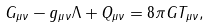<formula> <loc_0><loc_0><loc_500><loc_500>G _ { \mu \nu } - g _ { \mu \nu } \Lambda + Q _ { \mu \nu } = 8 \pi G T _ { \mu \nu } ,</formula> 